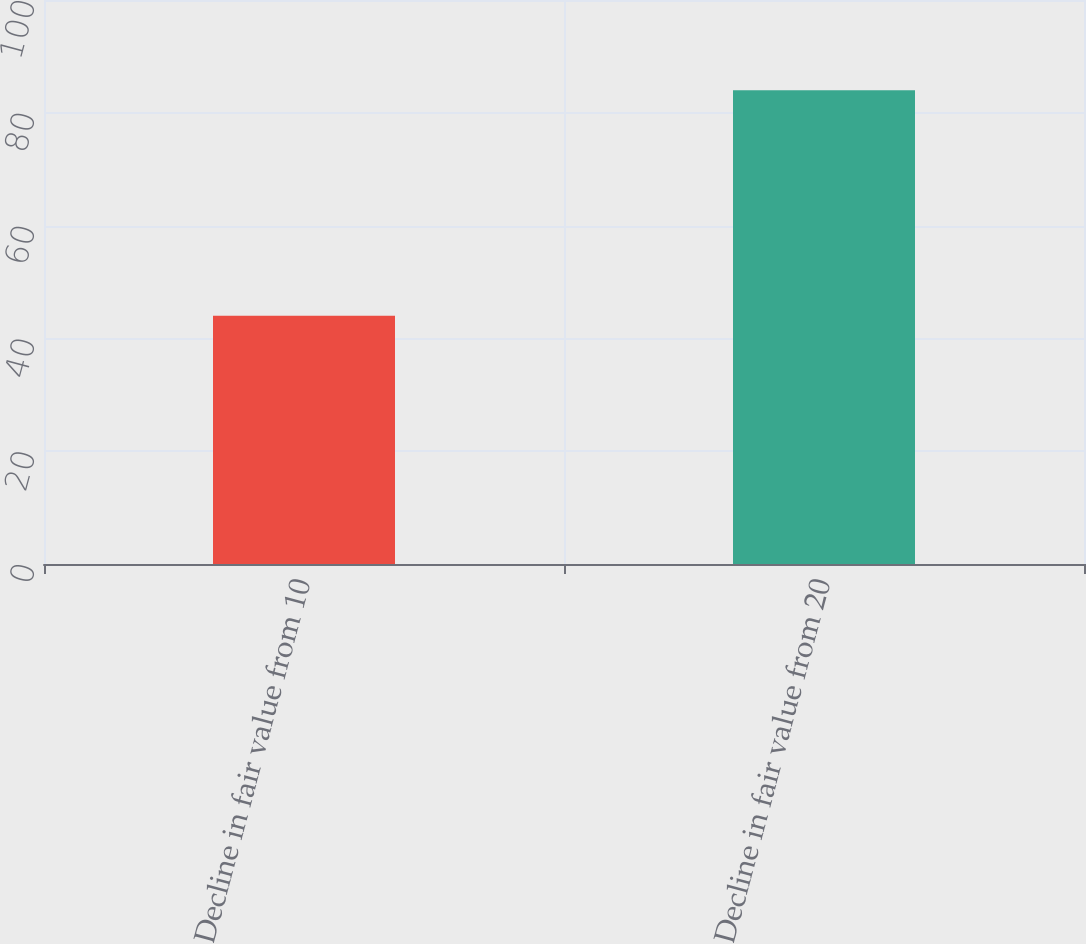Convert chart. <chart><loc_0><loc_0><loc_500><loc_500><bar_chart><fcel>Decline in fair value from 10<fcel>Decline in fair value from 20<nl><fcel>44<fcel>84<nl></chart> 